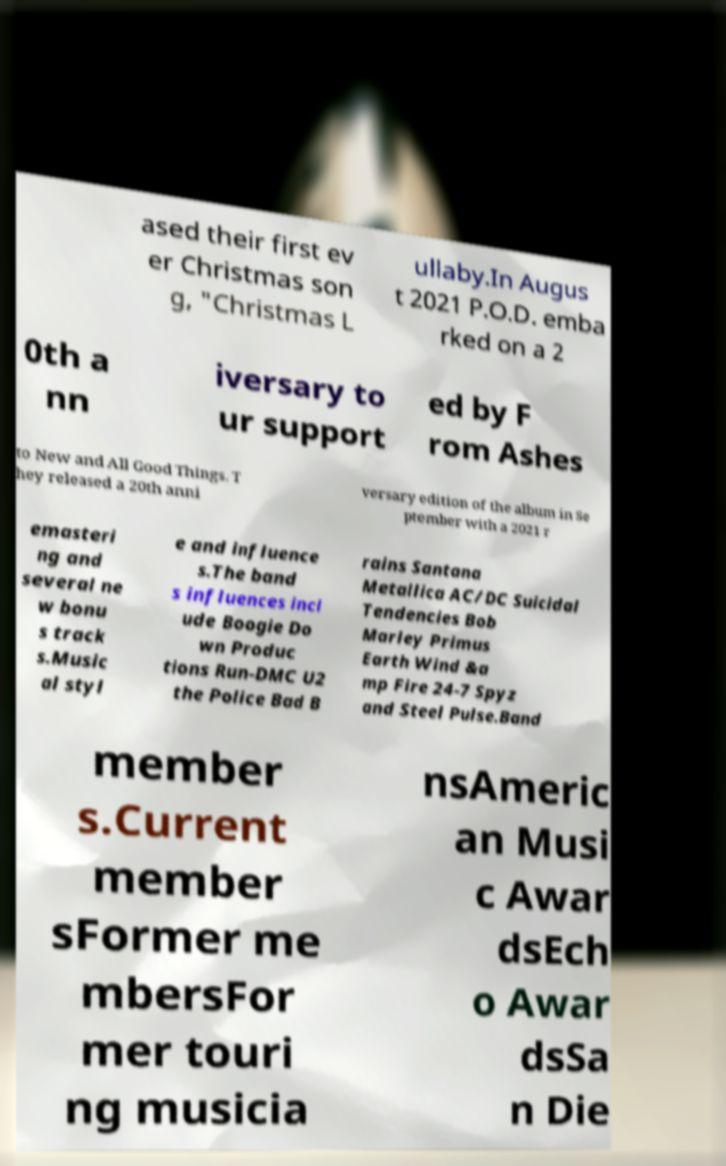I need the written content from this picture converted into text. Can you do that? ased their first ev er Christmas son g, "Christmas L ullaby.In Augus t 2021 P.O.D. emba rked on a 2 0th a nn iversary to ur support ed by F rom Ashes to New and All Good Things. T hey released a 20th anni versary edition of the album in Se ptember with a 2021 r emasteri ng and several ne w bonu s track s.Music al styl e and influence s.The band s influences incl ude Boogie Do wn Produc tions Run-DMC U2 the Police Bad B rains Santana Metallica AC/DC Suicidal Tendencies Bob Marley Primus Earth Wind &a mp Fire 24-7 Spyz and Steel Pulse.Band member s.Current member sFormer me mbersFor mer touri ng musicia nsAmeric an Musi c Awar dsEch o Awar dsSa n Die 